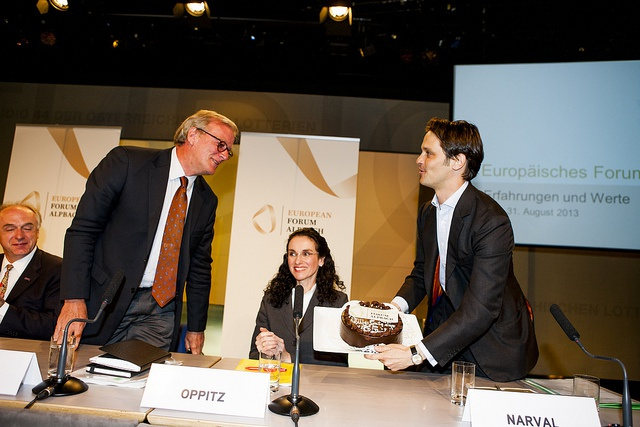Describe the objects in this image and their specific colors. I can see tv in black, lightblue, darkgray, and gray tones, people in black, brown, salmon, and lightgray tones, people in black, lightgray, tan, and maroon tones, people in black and tan tones, and people in black, brown, lightgray, and red tones in this image. 